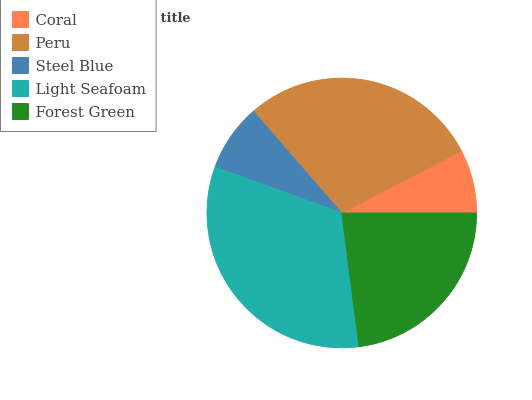Is Coral the minimum?
Answer yes or no. Yes. Is Light Seafoam the maximum?
Answer yes or no. Yes. Is Peru the minimum?
Answer yes or no. No. Is Peru the maximum?
Answer yes or no. No. Is Peru greater than Coral?
Answer yes or no. Yes. Is Coral less than Peru?
Answer yes or no. Yes. Is Coral greater than Peru?
Answer yes or no. No. Is Peru less than Coral?
Answer yes or no. No. Is Forest Green the high median?
Answer yes or no. Yes. Is Forest Green the low median?
Answer yes or no. Yes. Is Coral the high median?
Answer yes or no. No. Is Peru the low median?
Answer yes or no. No. 